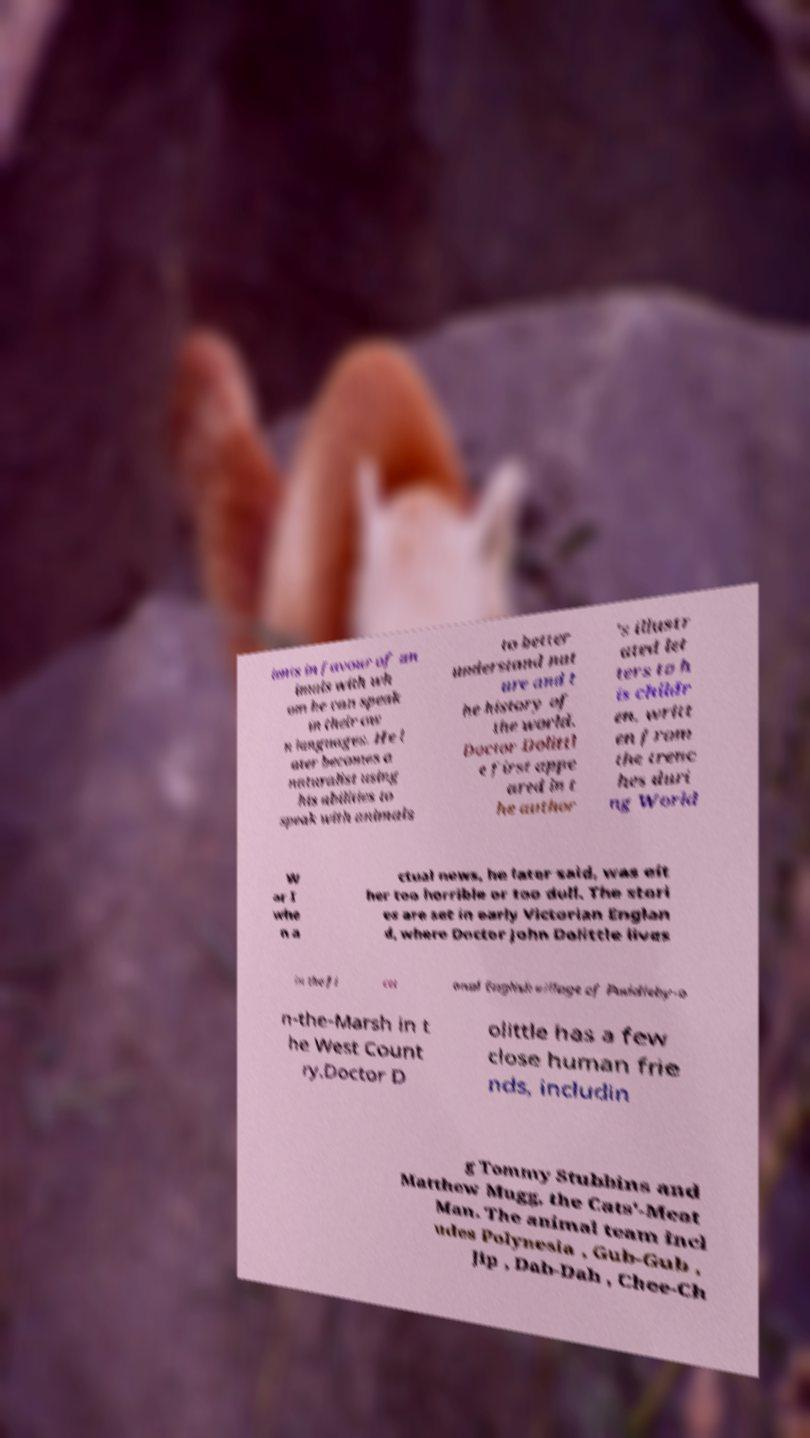Please identify and transcribe the text found in this image. ients in favour of an imals with wh om he can speak in their ow n languages. He l ater becomes a naturalist using his abilities to speak with animals to better understand nat ure and t he history of the world. Doctor Dolittl e first appe ared in t he author 's illustr ated let ters to h is childr en, writt en from the trenc hes duri ng World W ar I whe n a ctual news, he later said, was eit her too horrible or too dull. The stori es are set in early Victorian Englan d, where Doctor John Dolittle lives in the fi cti onal English village of Puddleby-o n-the-Marsh in t he West Count ry.Doctor D olittle has a few close human frie nds, includin g Tommy Stubbins and Matthew Mugg, the Cats'-Meat Man. The animal team incl udes Polynesia , Gub-Gub , Jip , Dab-Dab , Chee-Ch 